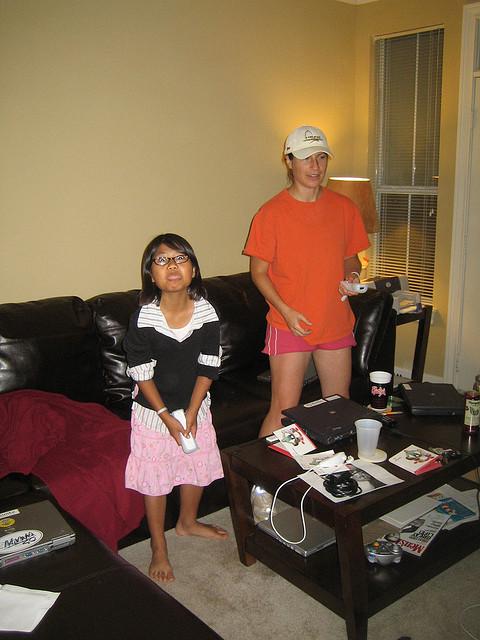What is the little girl holding?
Concise answer only. Controller. What gaming system are the people playing?
Short answer required. Wii. Are they related?
Short answer required. Yes. How many cups are on the coffee table?
Concise answer only. 2. 